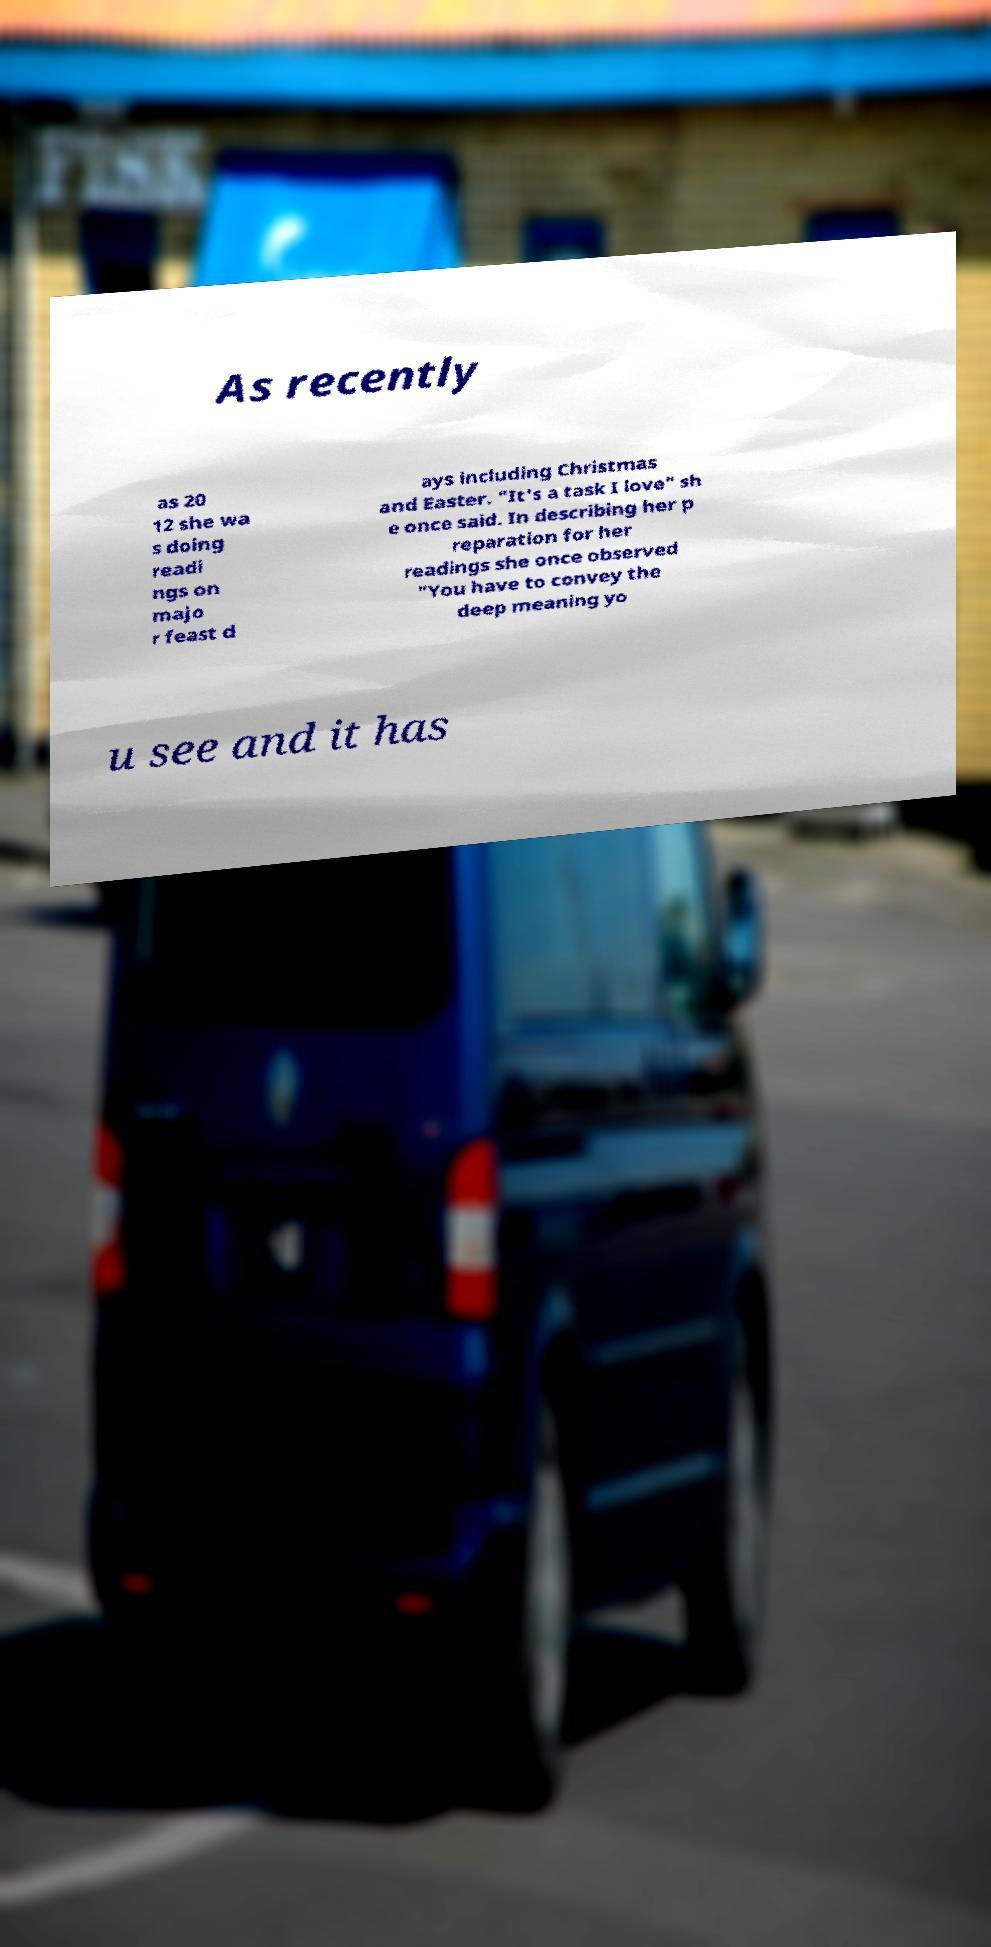Please read and relay the text visible in this image. What does it say? As recently as 20 12 she wa s doing readi ngs on majo r feast d ays including Christmas and Easter. "It's a task I love" sh e once said. In describing her p reparation for her readings she once observed "You have to convey the deep meaning yo u see and it has 